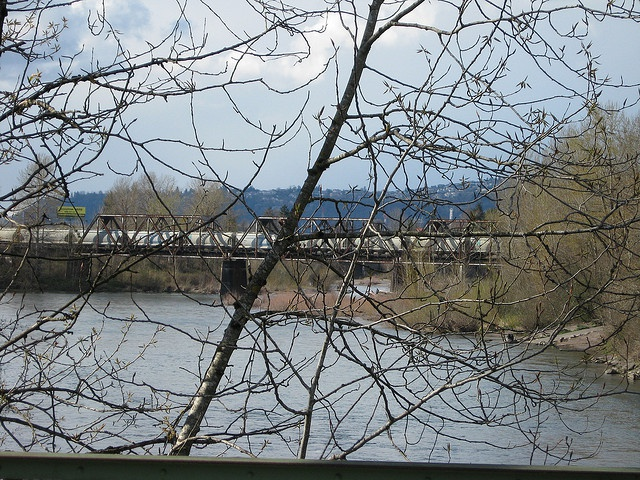Describe the objects in this image and their specific colors. I can see a train in black, gray, darkgray, and lightgray tones in this image. 